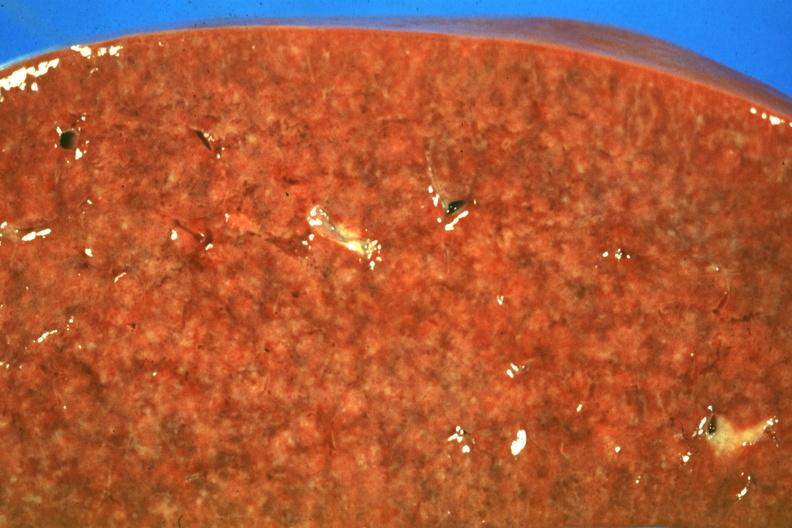where is this part in?
Answer the question using a single word or phrase. Spleen 